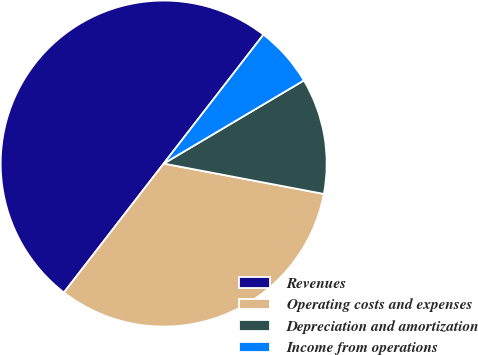<chart> <loc_0><loc_0><loc_500><loc_500><pie_chart><fcel>Revenues<fcel>Operating costs and expenses<fcel>Depreciation and amortization<fcel>Income from operations<nl><fcel>50.0%<fcel>32.5%<fcel>11.5%<fcel>6.0%<nl></chart> 